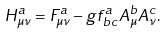<formula> <loc_0><loc_0><loc_500><loc_500>H _ { \mu \nu } ^ { a } = F _ { \mu \nu } ^ { a } - g f _ { \, b c } ^ { a } A _ { \mu } ^ { b } A _ { \nu } ^ { c } .</formula> 